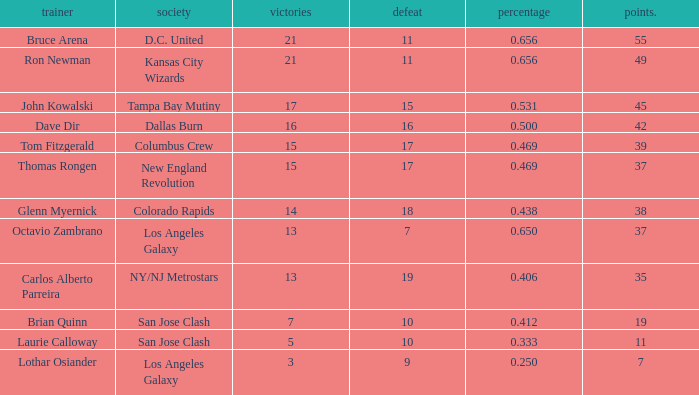What is the sum of points when Bruce Arena has 21 wins? 55.0. Parse the table in full. {'header': ['trainer', 'society', 'victories', 'defeat', 'percentage', 'points.'], 'rows': [['Bruce Arena', 'D.C. United', '21', '11', '0.656', '55'], ['Ron Newman', 'Kansas City Wizards', '21', '11', '0.656', '49'], ['John Kowalski', 'Tampa Bay Mutiny', '17', '15', '0.531', '45'], ['Dave Dir', 'Dallas Burn', '16', '16', '0.500', '42'], ['Tom Fitzgerald', 'Columbus Crew', '15', '17', '0.469', '39'], ['Thomas Rongen', 'New England Revolution', '15', '17', '0.469', '37'], ['Glenn Myernick', 'Colorado Rapids', '14', '18', '0.438', '38'], ['Octavio Zambrano', 'Los Angeles Galaxy', '13', '7', '0.650', '37'], ['Carlos Alberto Parreira', 'NY/NJ Metrostars', '13', '19', '0.406', '35'], ['Brian Quinn', 'San Jose Clash', '7', '10', '0.412', '19'], ['Laurie Calloway', 'San Jose Clash', '5', '10', '0.333', '11'], ['Lothar Osiander', 'Los Angeles Galaxy', '3', '9', '0.250', '7']]} 